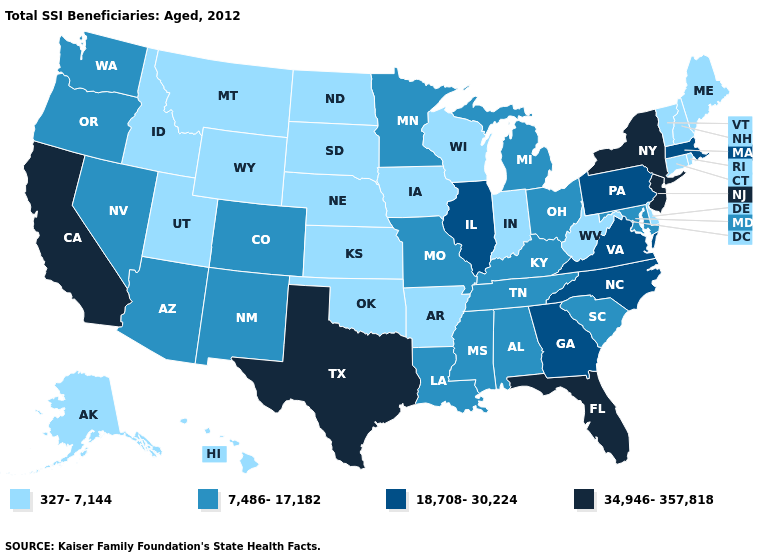What is the value of Oklahoma?
Quick response, please. 327-7,144. What is the value of Texas?
Be succinct. 34,946-357,818. Name the states that have a value in the range 327-7,144?
Answer briefly. Alaska, Arkansas, Connecticut, Delaware, Hawaii, Idaho, Indiana, Iowa, Kansas, Maine, Montana, Nebraska, New Hampshire, North Dakota, Oklahoma, Rhode Island, South Dakota, Utah, Vermont, West Virginia, Wisconsin, Wyoming. Does Kansas have the same value as Arkansas?
Keep it brief. Yes. What is the lowest value in states that border Mississippi?
Concise answer only. 327-7,144. Name the states that have a value in the range 18,708-30,224?
Answer briefly. Georgia, Illinois, Massachusetts, North Carolina, Pennsylvania, Virginia. Does Indiana have the same value as Washington?
Write a very short answer. No. What is the value of Georgia?
Write a very short answer. 18,708-30,224. What is the highest value in states that border Pennsylvania?
Answer briefly. 34,946-357,818. What is the value of Colorado?
Give a very brief answer. 7,486-17,182. Does the first symbol in the legend represent the smallest category?
Answer briefly. Yes. Among the states that border Montana , which have the highest value?
Answer briefly. Idaho, North Dakota, South Dakota, Wyoming. Among the states that border Colorado , which have the highest value?
Give a very brief answer. Arizona, New Mexico. What is the value of Oregon?
Keep it brief. 7,486-17,182. What is the lowest value in the USA?
Short answer required. 327-7,144. 